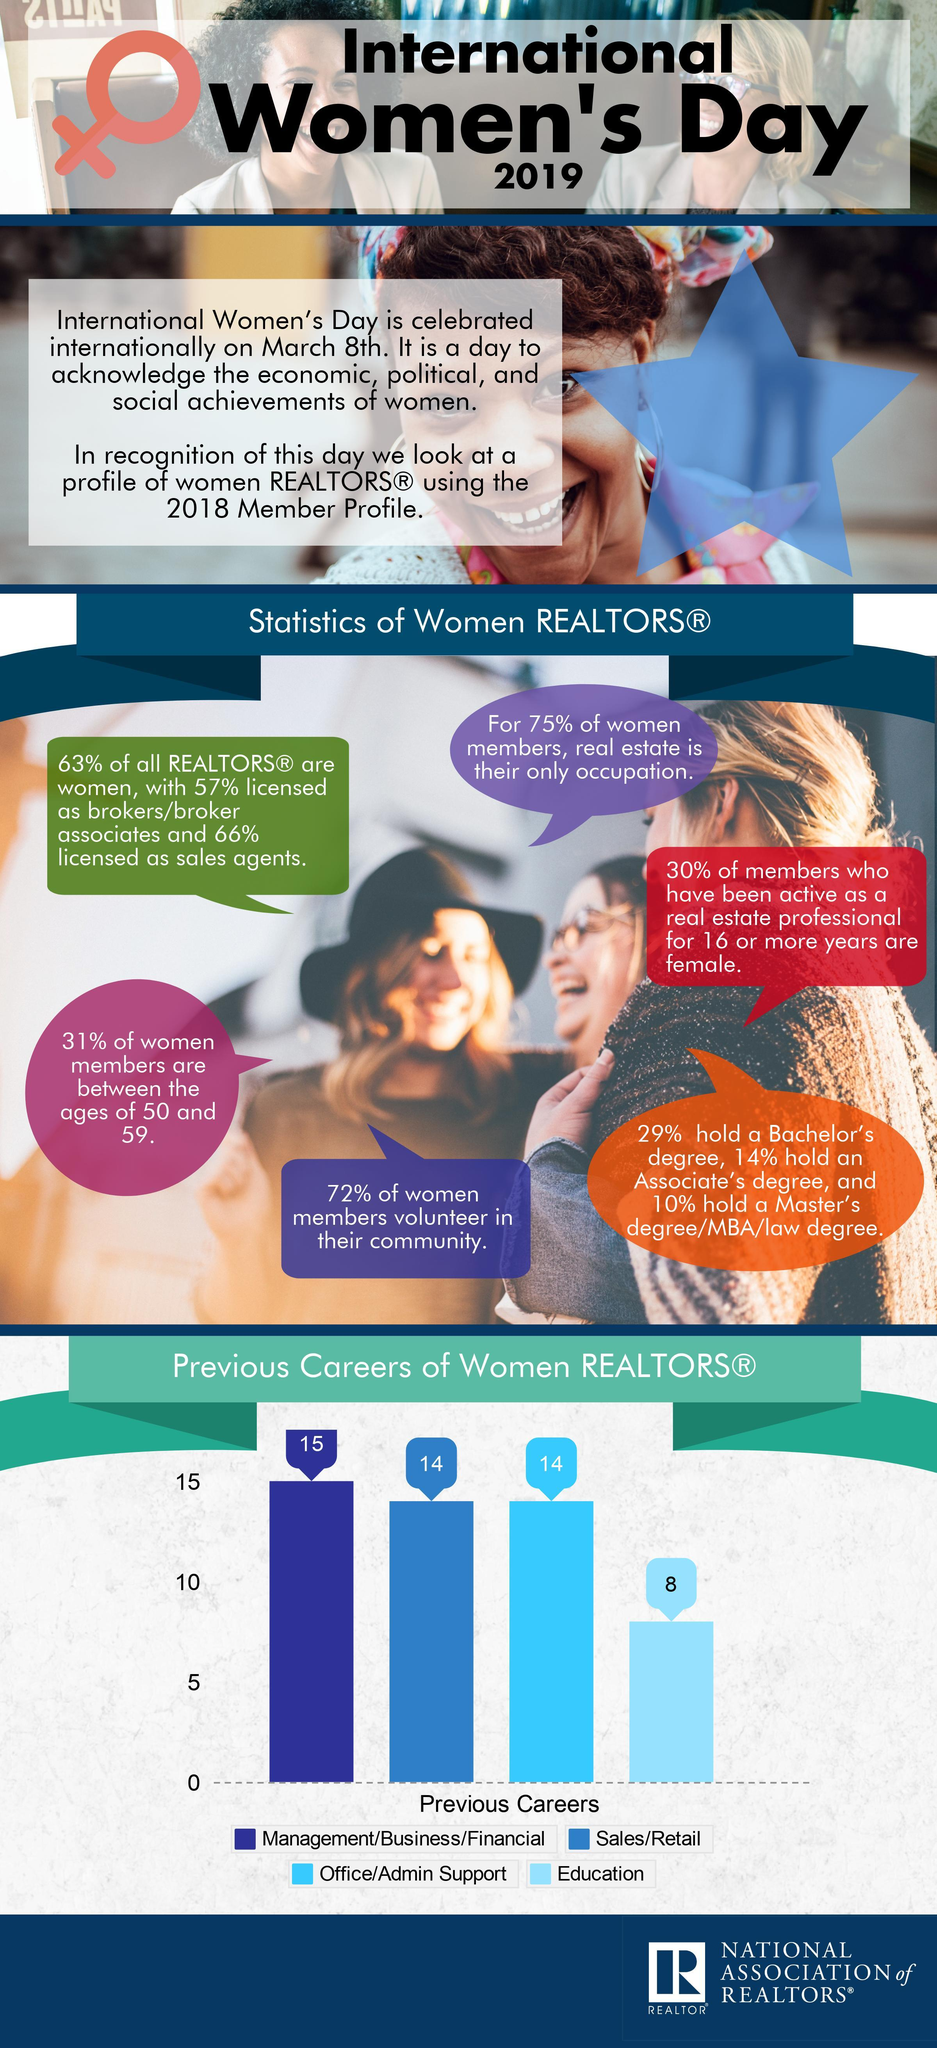What percentage not licensed as brokers?
Answer the question with a short phrase. 43% What percentage of women members are not between the ages of 50 and 59? 69% What percentage of Realtors are not women? 37% What percentage not licensed as sales agents? 34% What percentage of women didn't hold a Bachelor's degree? 71% 